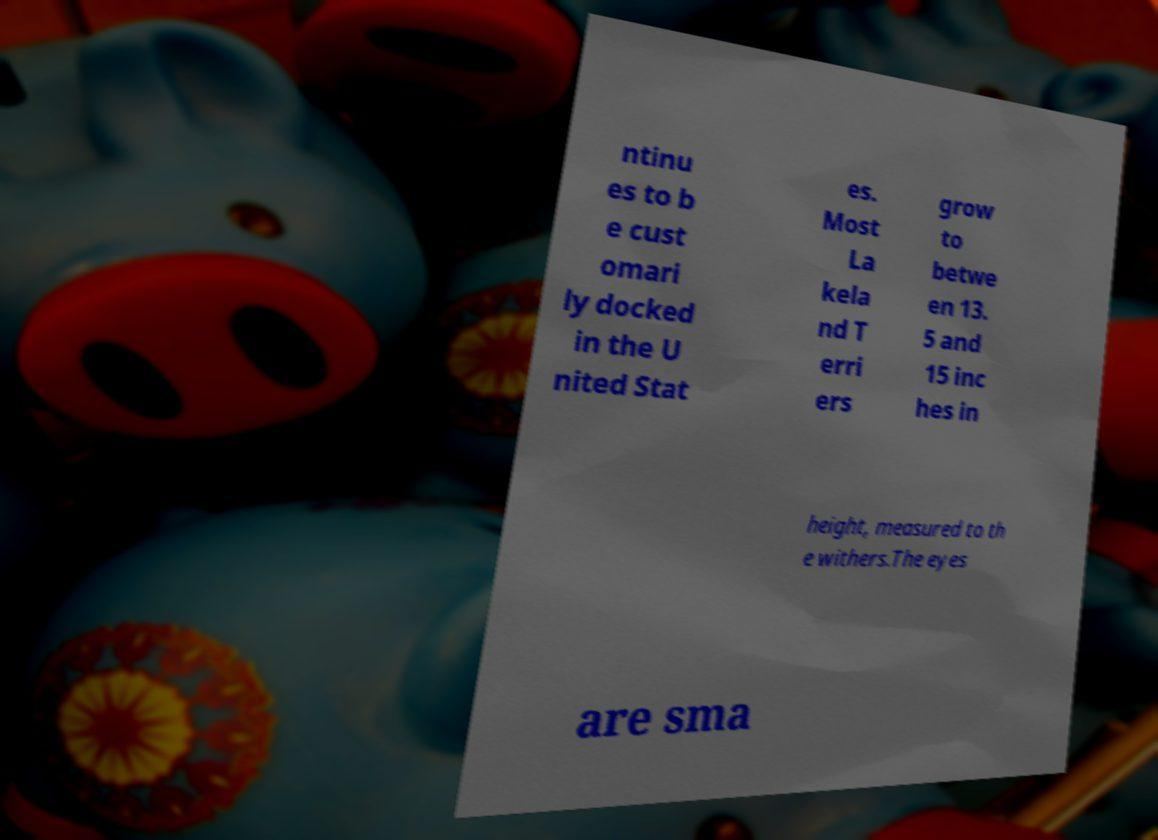What messages or text are displayed in this image? I need them in a readable, typed format. ntinu es to b e cust omari ly docked in the U nited Stat es. Most La kela nd T erri ers grow to betwe en 13. 5 and 15 inc hes in height, measured to th e withers.The eyes are sma 